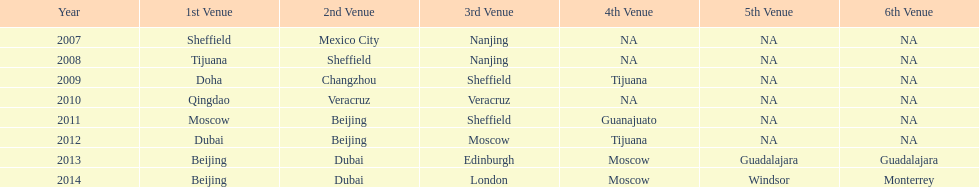What year had the same second event venue as the one in 2011? 2012. 